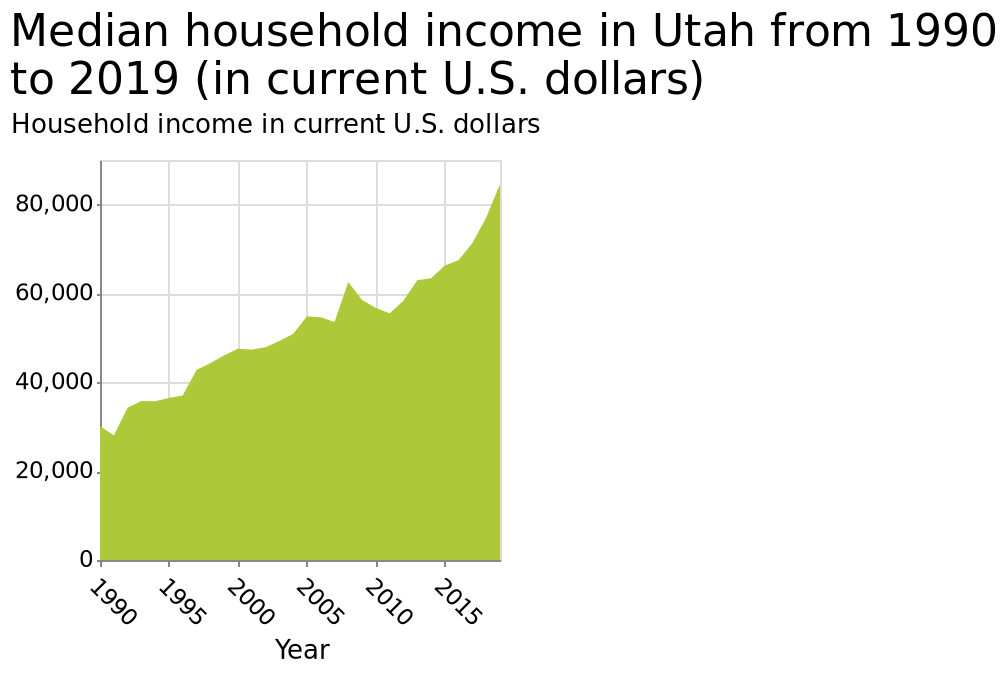<image>
What was the approximate median household income in Utah in 2019?  The approximate median household income in Utah in 2019 was around $85,000. 